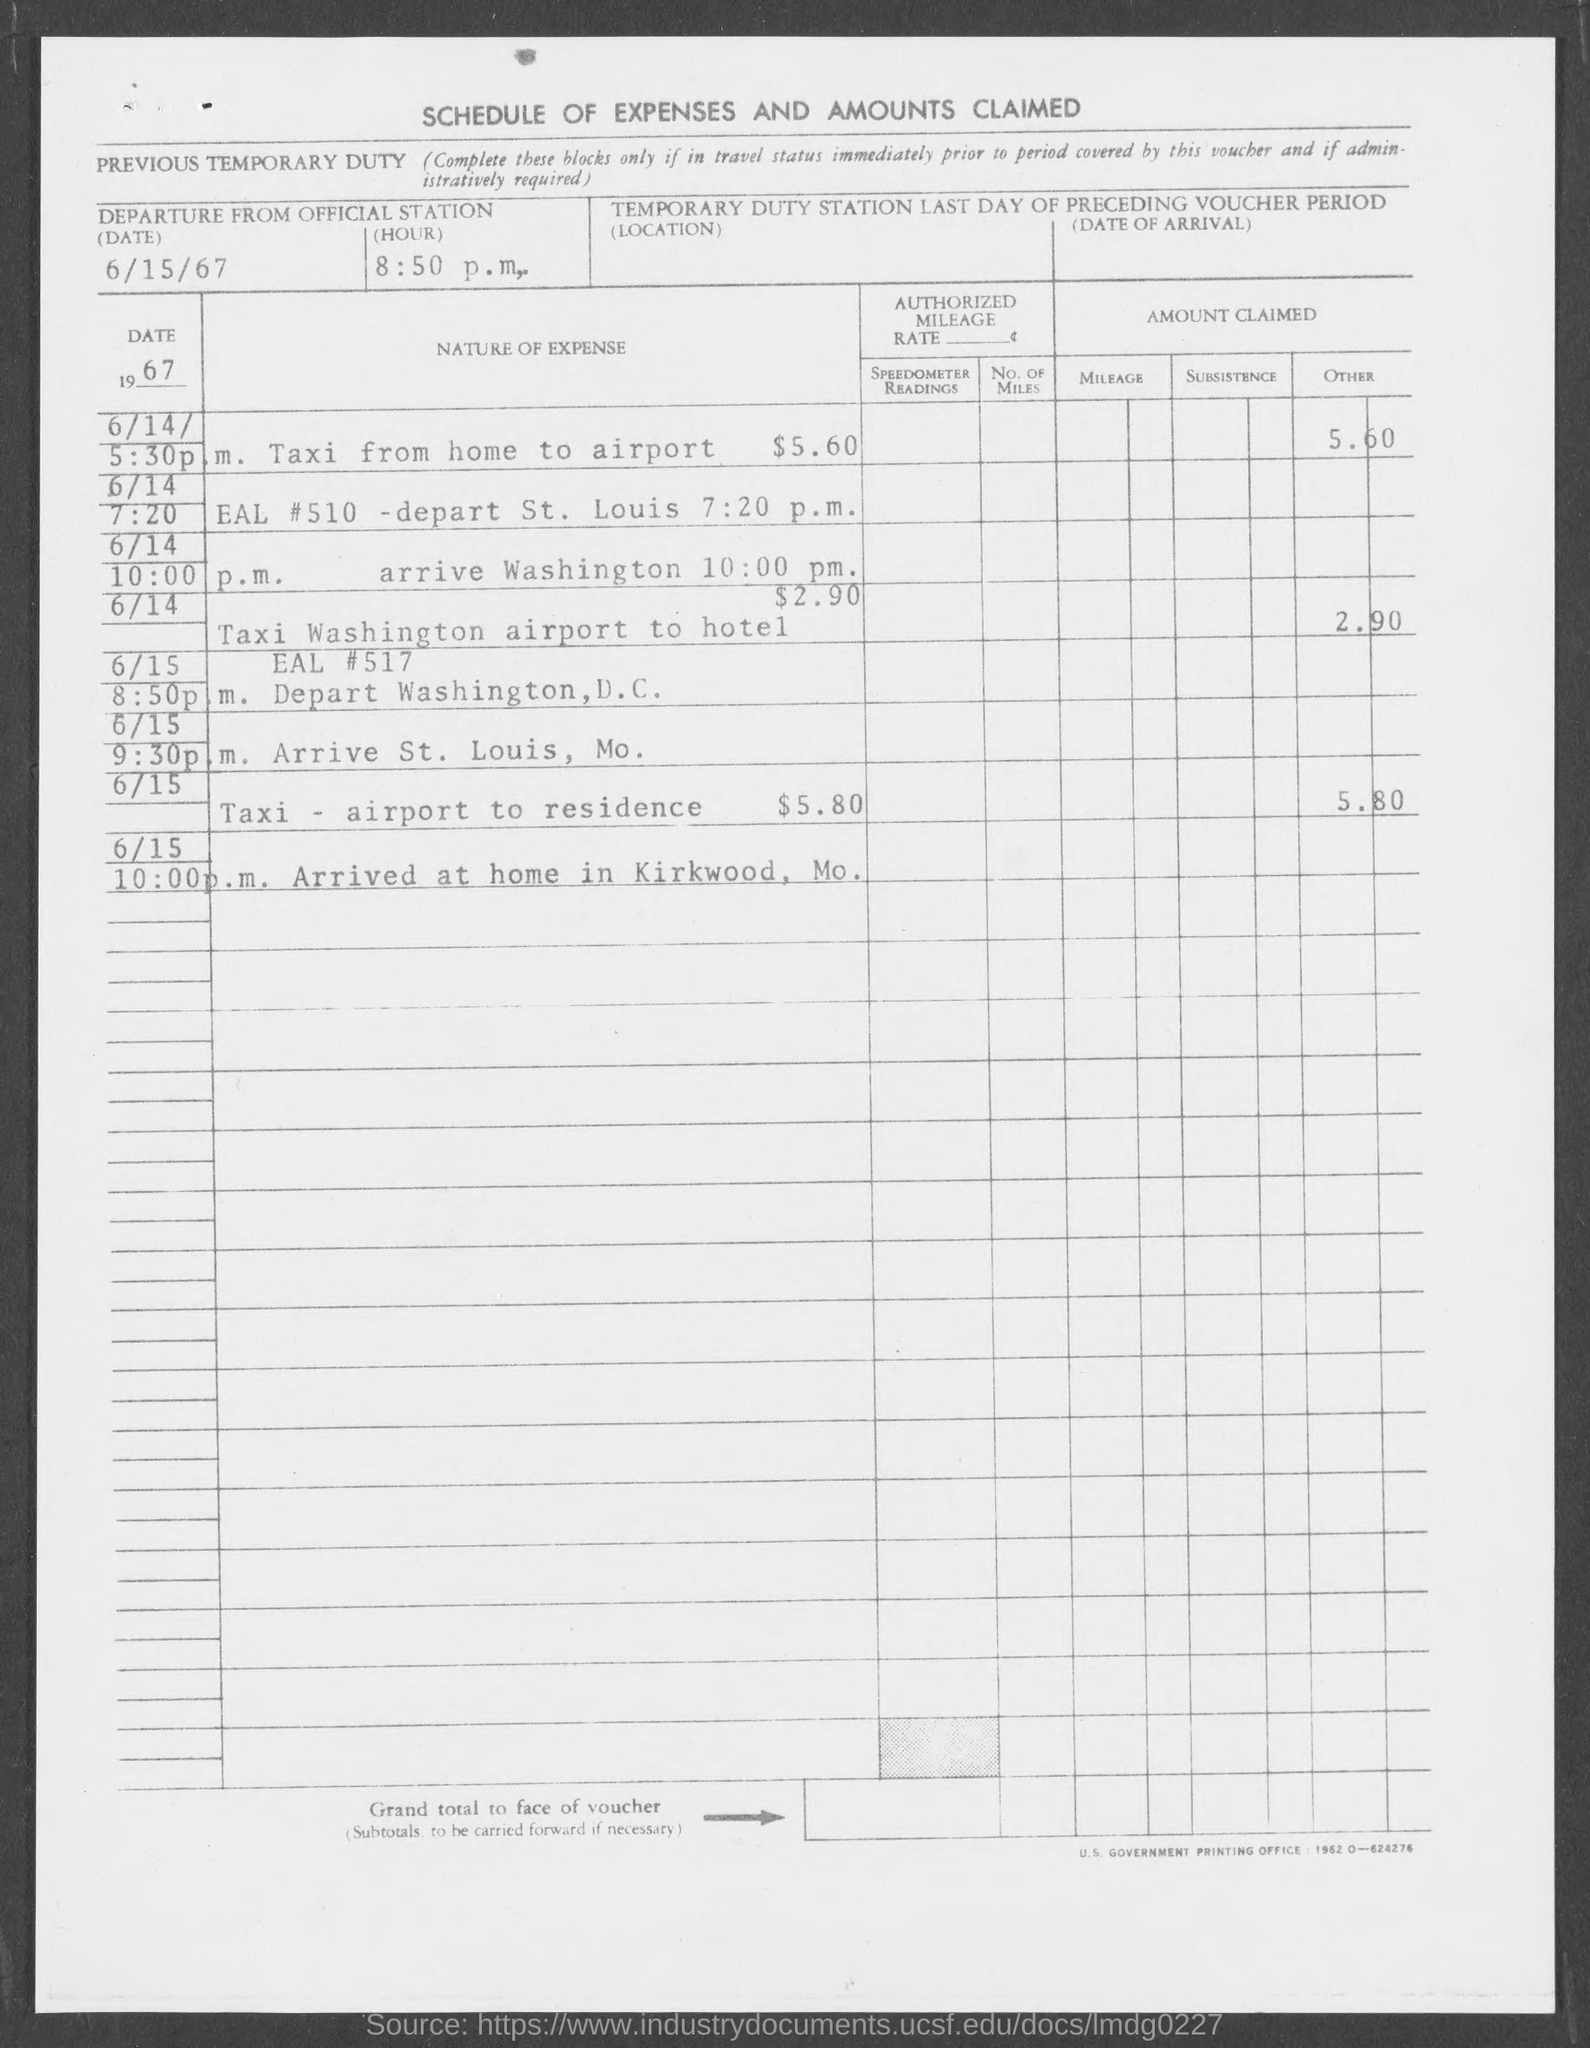What is the document title?
Offer a terse response. Schedule of expenses and amounts claimed. What is the departure date from official station?
Your response must be concise. 6/15/67. What is the time of departure from official station?
Give a very brief answer. 8:50 p.m. 